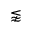Convert formula to latex. <formula><loc_0><loc_0><loc_500><loc_500>\lnapprox</formula> 